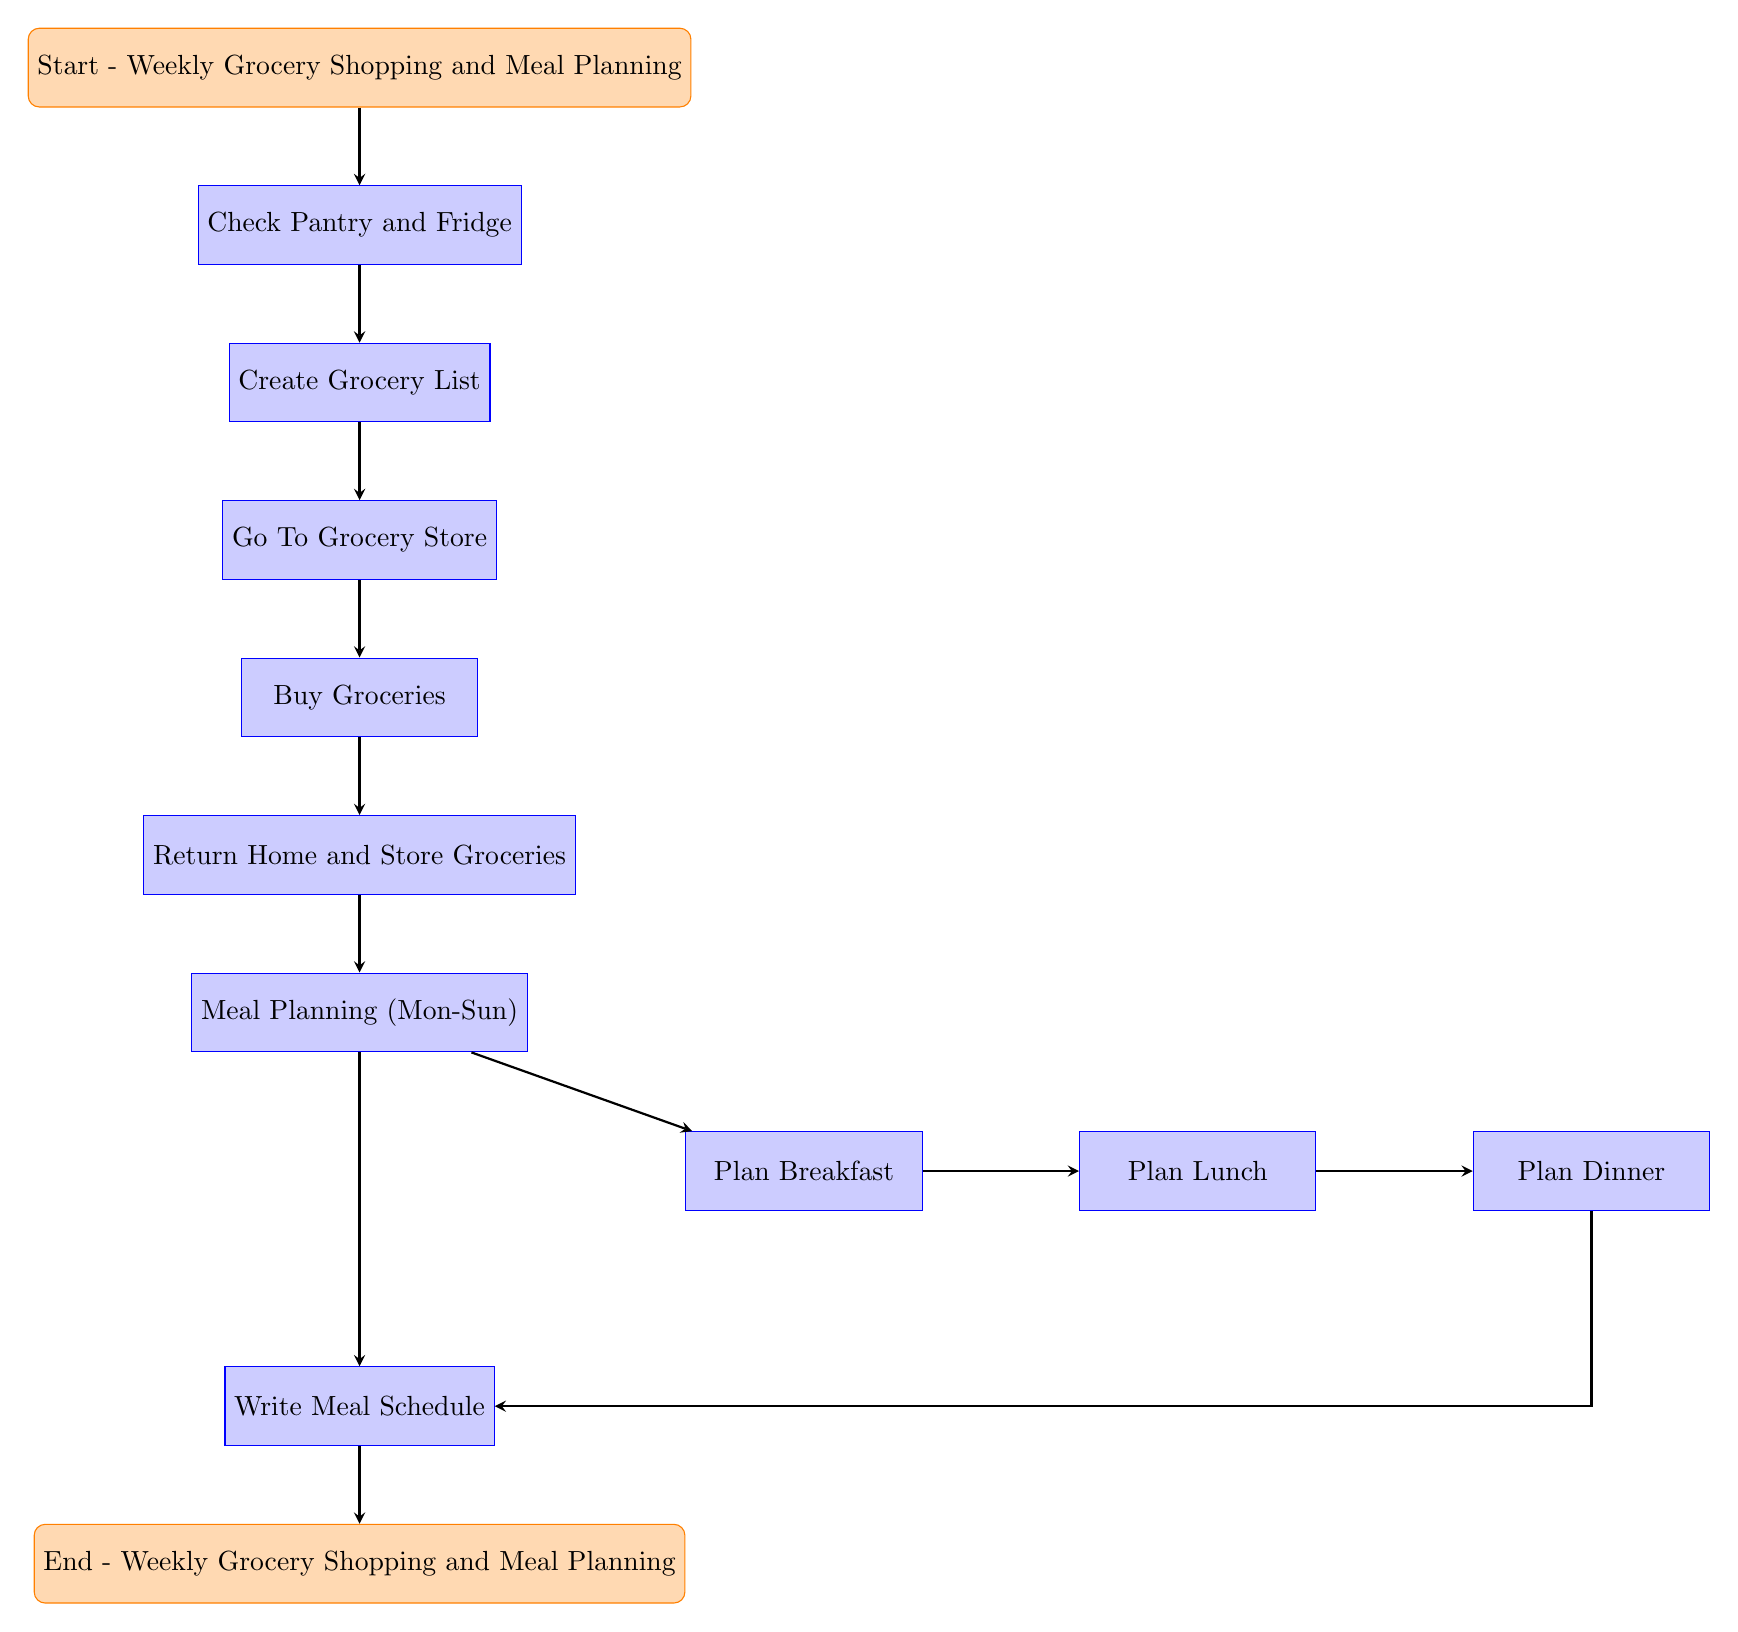What is the starting point of the flow chart? The flow chart begins with the node labeled "Start - Weekly Grocery Shopping and Meal Planning". This information can be found at the top of the diagram, indicating where the process initiates.
Answer: Start - Weekly Grocery Shopping and Meal Planning How many processes are involved in the meal planning? There are a total of eight processes in the flow chart: Check Pantry and Fridge, Create Grocery List, Go To Grocery Store, Buy Groceries, Return Home and Store Groceries, Meal Planning (Mon-Sun), Write Meal Schedule, and the meal planning for breakfast, lunch, and dinner which are separate nodes.
Answer: Eight What is the final step in the process? The last node, also known as the ending point of the flow chart, is labeled "End - Weekly Grocery Shopping and Meal Planning", indicating the conclusion of the entire process.
Answer: End - Weekly Grocery Shopping and Meal Planning Which node directly follows the "Check Pantry and Fridge" process? The node that follows "Check Pantry and Fridge" is labeled "Create Grocery List". This is indicated by the direct connection from the "Check Pantry and Fridge" node to the "Create Grocery List" node.
Answer: Create Grocery List What flows directly into the "Write Meal Schedule" node? The "Write Meal Schedule" node receives connections from both the "Plan Dinner" node and the "Meal Planning (Mon-Sun)" node. This indicates that meal planning is a prerequisite for writing the meal schedule.
Answer: Plan Dinner and Meal Planning (Mon-Sun) What are the three types of meals planned in the diagram? The three types of meals that are specifically planned in the diagram are Breakfast, Lunch, and Dinner, each represented by their respective nodes that provide examples of foods.
Answer: Breakfast, Lunch, Dinner How many nodes represent meal planning specifically? There are four distinct nodes dedicated to meal planning in the diagram: "Plan Breakfast", "Plan Lunch", "Plan Dinner", and "Write Meal Schedule". This totals to four nodes that deal directly with meal planning.
Answer: Four What connects "Return Home and Store Groceries" to "Meal Planning (Mon-Sun)"? The process of returning home and storing groceries is sequentially followed by the meal planning step, as shown by the directed arrow connecting these two nodes. This indicates that after groceries are stored, meal planning begins.
Answer: Directed arrow 